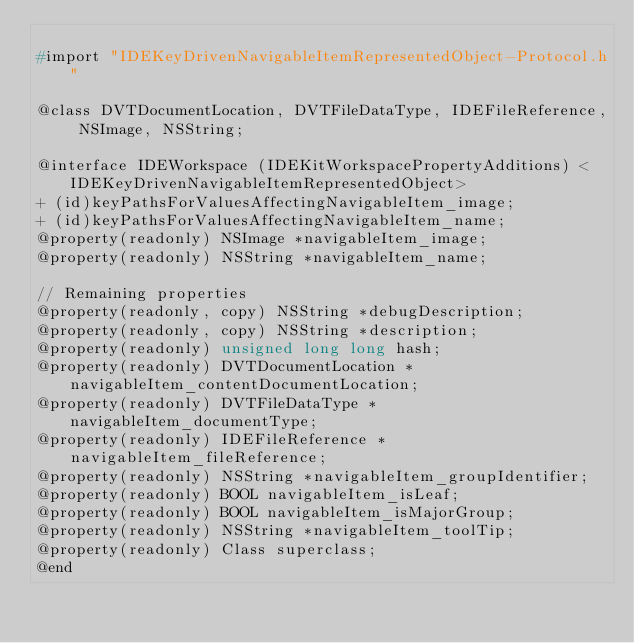Convert code to text. <code><loc_0><loc_0><loc_500><loc_500><_C_>
#import "IDEKeyDrivenNavigableItemRepresentedObject-Protocol.h"

@class DVTDocumentLocation, DVTFileDataType, IDEFileReference, NSImage, NSString;

@interface IDEWorkspace (IDEKitWorkspacePropertyAdditions) <IDEKeyDrivenNavigableItemRepresentedObject>
+ (id)keyPathsForValuesAffectingNavigableItem_image;
+ (id)keyPathsForValuesAffectingNavigableItem_name;
@property(readonly) NSImage *navigableItem_image;
@property(readonly) NSString *navigableItem_name;

// Remaining properties
@property(readonly, copy) NSString *debugDescription;
@property(readonly, copy) NSString *description;
@property(readonly) unsigned long long hash;
@property(readonly) DVTDocumentLocation *navigableItem_contentDocumentLocation;
@property(readonly) DVTFileDataType *navigableItem_documentType;
@property(readonly) IDEFileReference *navigableItem_fileReference;
@property(readonly) NSString *navigableItem_groupIdentifier;
@property(readonly) BOOL navigableItem_isLeaf;
@property(readonly) BOOL navigableItem_isMajorGroup;
@property(readonly) NSString *navigableItem_toolTip;
@property(readonly) Class superclass;
@end

</code> 